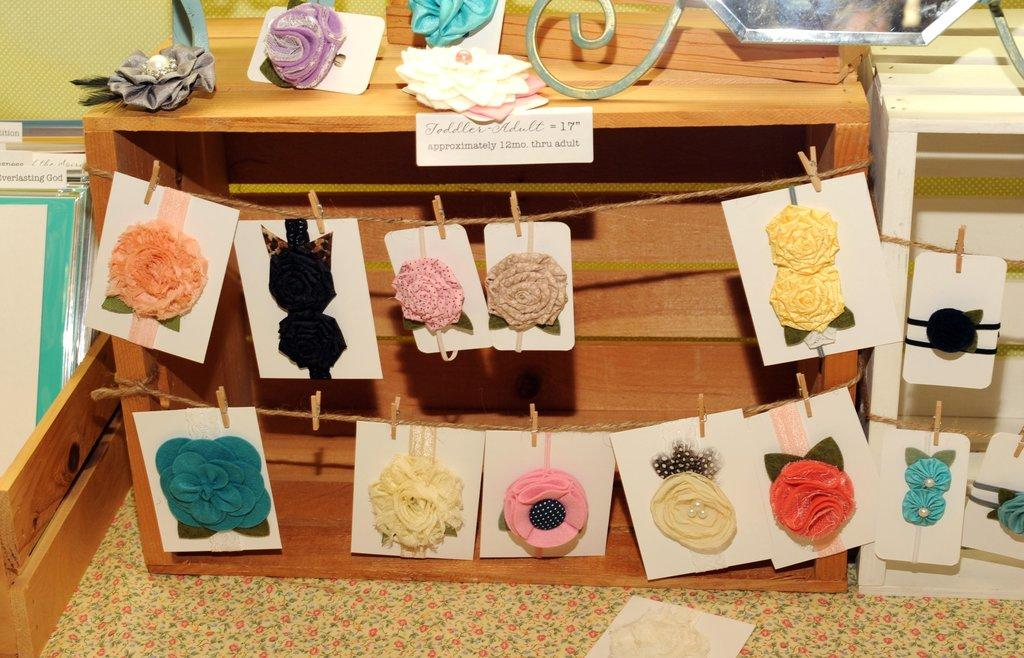What type of accessory is visible in the image? There are hair bands in the image. How are the hair bands arranged in the image? The hair bands are hanged on a rope. What is used to hang the hair bands on the rope? The rope has clips attached to it. What type of mitten can be seen attacking the hair bands in the image? There is no mitten present in the image, and therefore no such attack can be observed. 